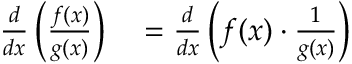<formula> <loc_0><loc_0><loc_500><loc_500>\begin{array} { r l } { { \frac { d } { d x } } \left ( { \frac { f ( x ) } { g ( x ) } } \right ) } & = { \frac { d } { d x } } \left ( f ( x ) \cdot { \frac { 1 } { g ( x ) } } \right ) } \end{array}</formula> 